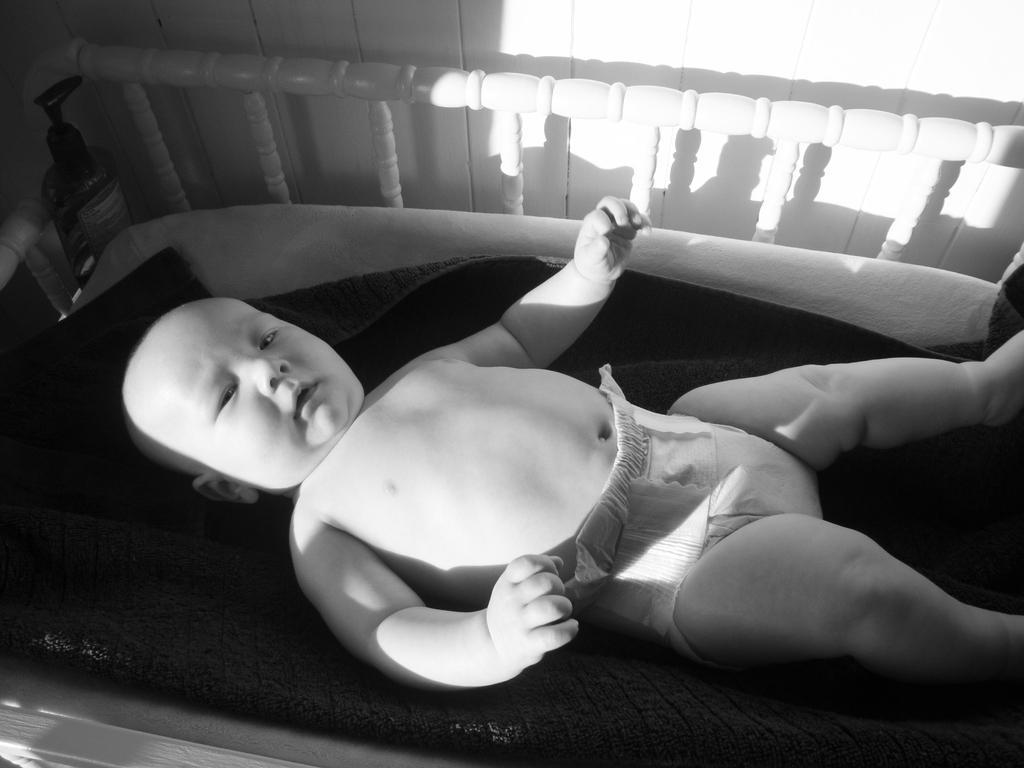Please provide a concise description of this image. In this image we can see a baby. There is a bed in the image. There is a wooden wall in the image. 